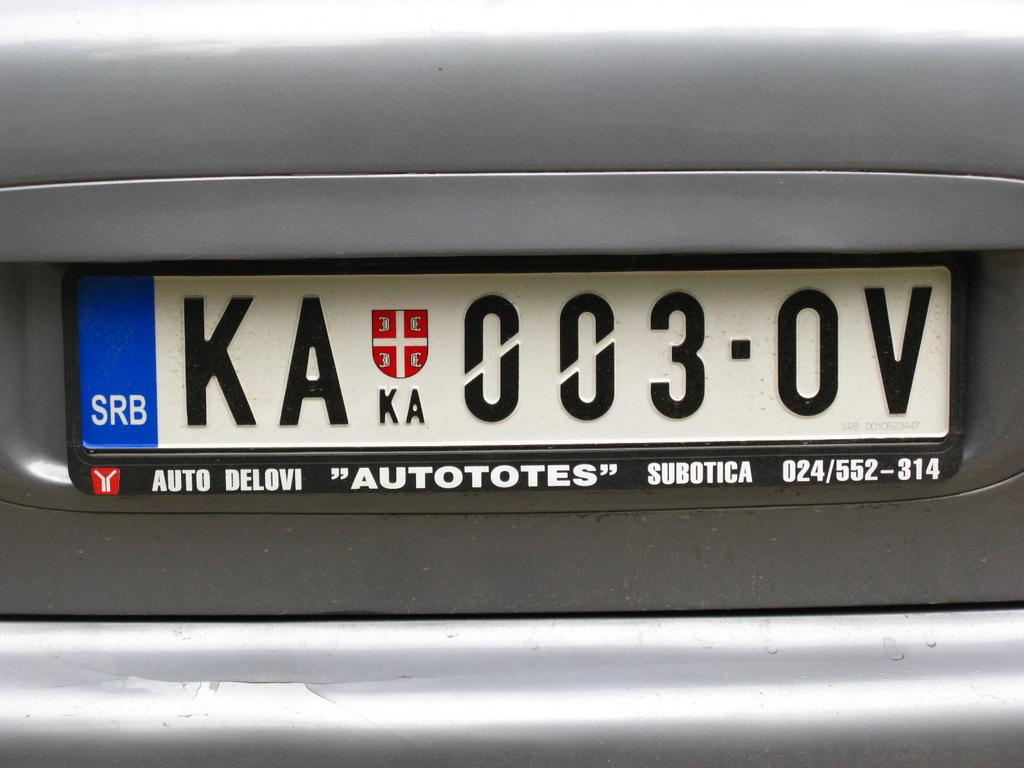What is the license plate number of the car?
Keep it short and to the point. Ka 003-0v. What word appears in quotation marks on the license plate border?
Ensure brevity in your answer.  Autototes. 